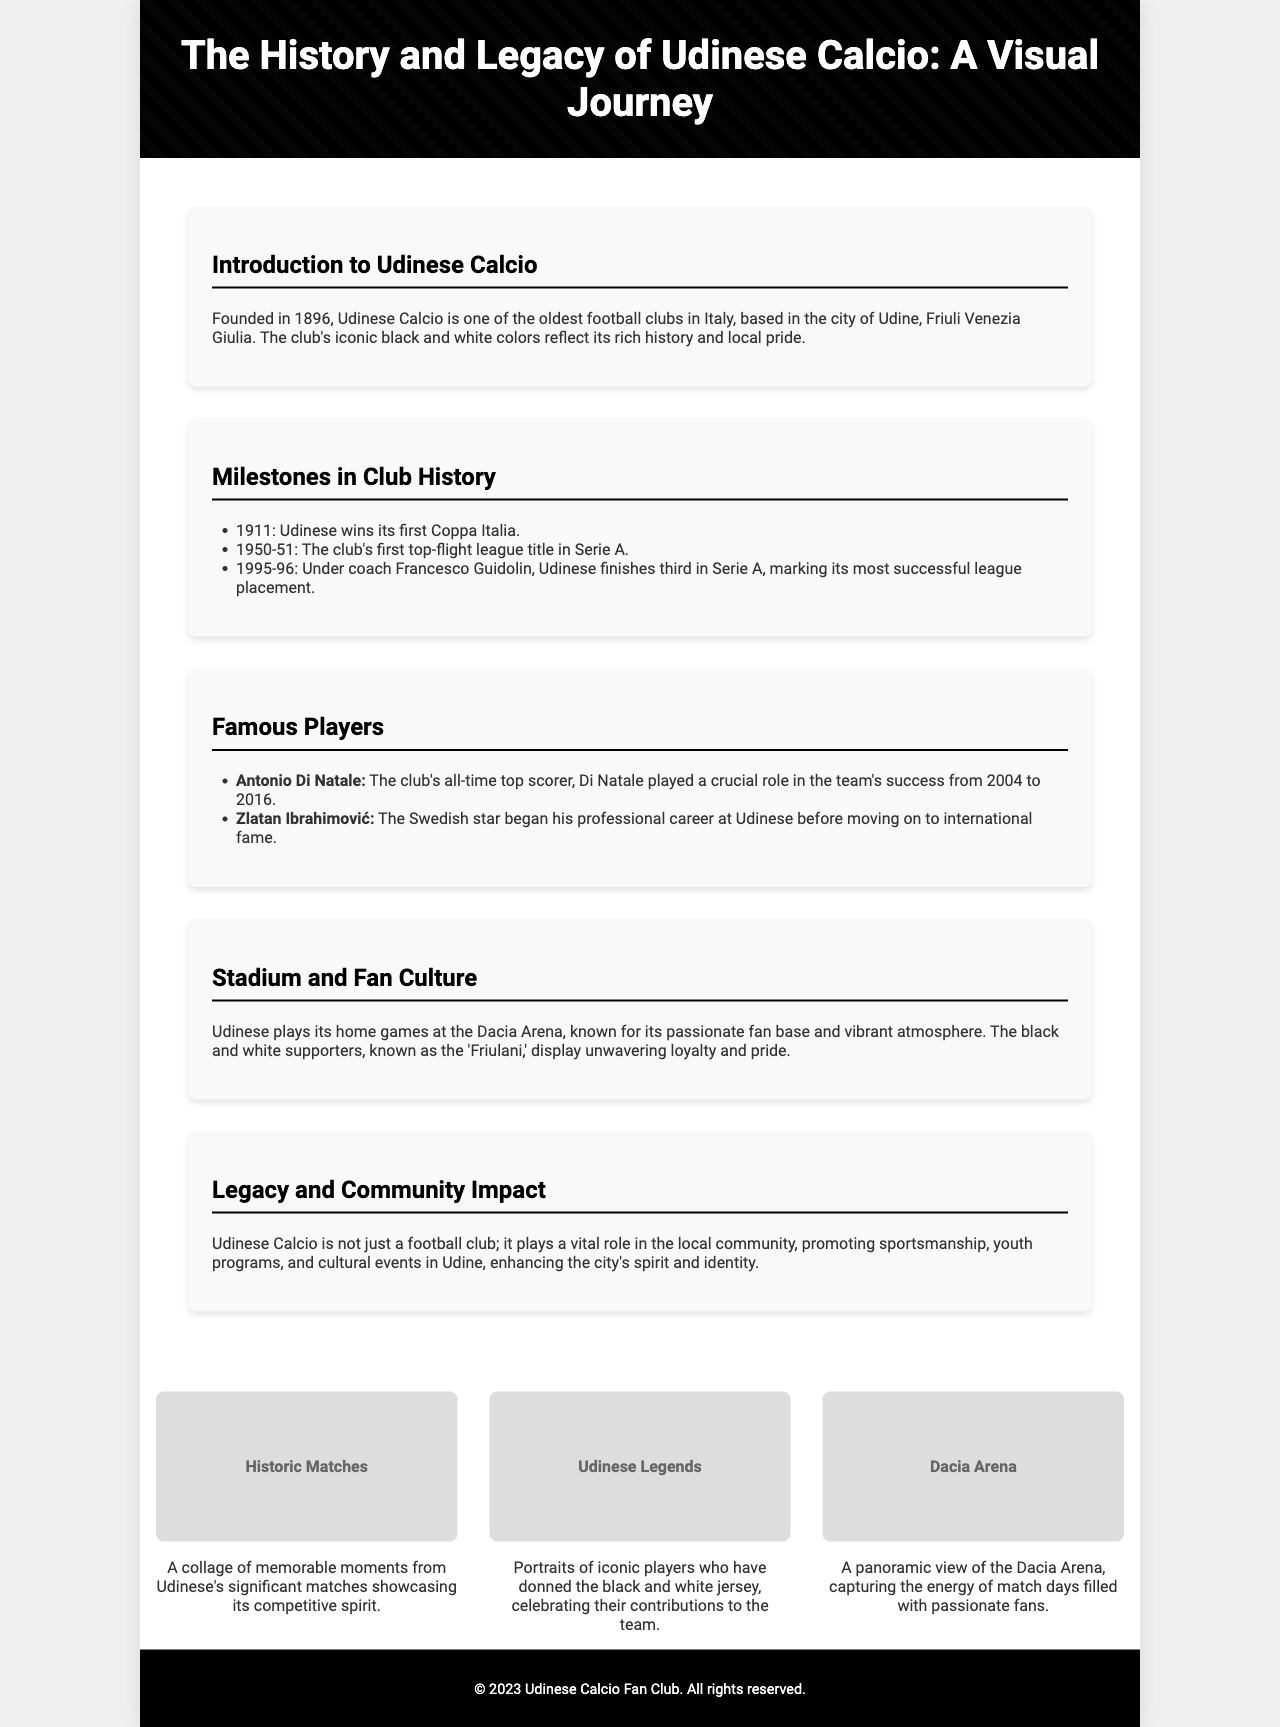what year was Udinese Calcio founded? The document states that Udinese Calcio was founded in 1896.
Answer: 1896 who is Udinese's all-time top scorer? The document mentions that Antonio Di Natale is the club's all-time top scorer.
Answer: Antonio Di Natale what is the name of Udinese's home stadium? The document reveals that Udinese plays its home games at the Dacia Arena.
Answer: Dacia Arena how many Coppa Italia titles did Udinese win by 1911? The document indicates that Udinese won its first Coppa Italia in 1911.
Answer: 1 who was the coach when Udinese finished third in Serie A in 1995-96? The document states that Francesco Guidolin was the coach during that season.
Answer: Francesco Guidolin what is a significant aspect of Udinese's legacy in the community? The document discusses Udinese's role in promoting sportsmanship and youth programs in the local area.
Answer: Community impact which colors represent Udinese Calcio? The document notes that the club's iconic colors are black and white.
Answer: Black and white when did Zlatan Ibrahimović begin his professional career at Udinese? The document does not specify a year but states that he began at Udinese before moving on to international fame.
Answer: No specific year given 